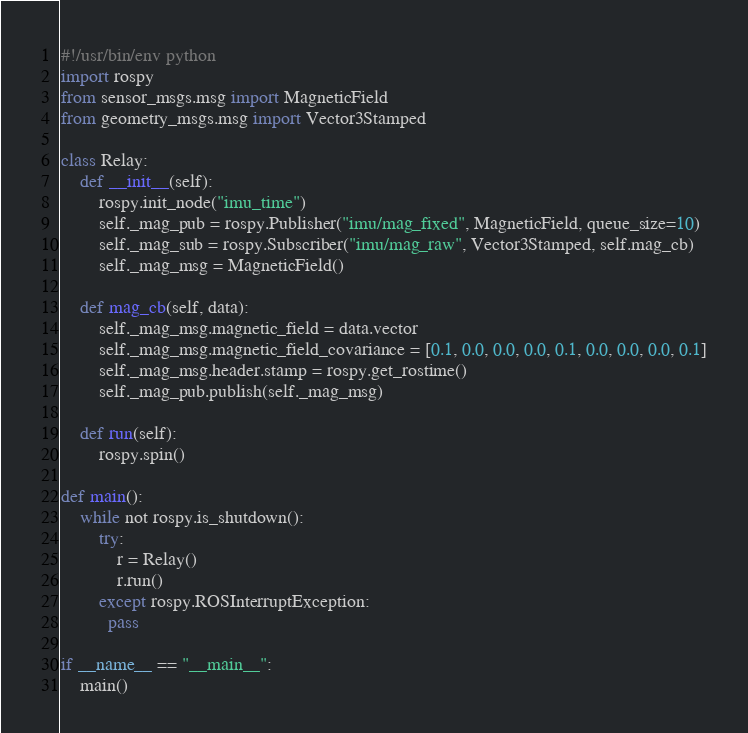Convert code to text. <code><loc_0><loc_0><loc_500><loc_500><_Python_>#!/usr/bin/env python
import rospy
from sensor_msgs.msg import MagneticField
from geometry_msgs.msg import Vector3Stamped

class Relay:
    def __init__(self):
        rospy.init_node("imu_time")
        self._mag_pub = rospy.Publisher("imu/mag_fixed", MagneticField, queue_size=10)
        self._mag_sub = rospy.Subscriber("imu/mag_raw", Vector3Stamped, self.mag_cb)
        self._mag_msg = MagneticField()

    def mag_cb(self, data):
        self._mag_msg.magnetic_field = data.vector
        self._mag_msg.magnetic_field_covariance = [0.1, 0.0, 0.0, 0.0, 0.1, 0.0, 0.0, 0.0, 0.1]
        self._mag_msg.header.stamp = rospy.get_rostime()
        self._mag_pub.publish(self._mag_msg)

    def run(self):
        rospy.spin()

def main():
    while not rospy.is_shutdown():
        try:
            r = Relay()
            r.run()
        except rospy.ROSInterruptException:
          pass

if __name__ == "__main__":
    main()
</code> 